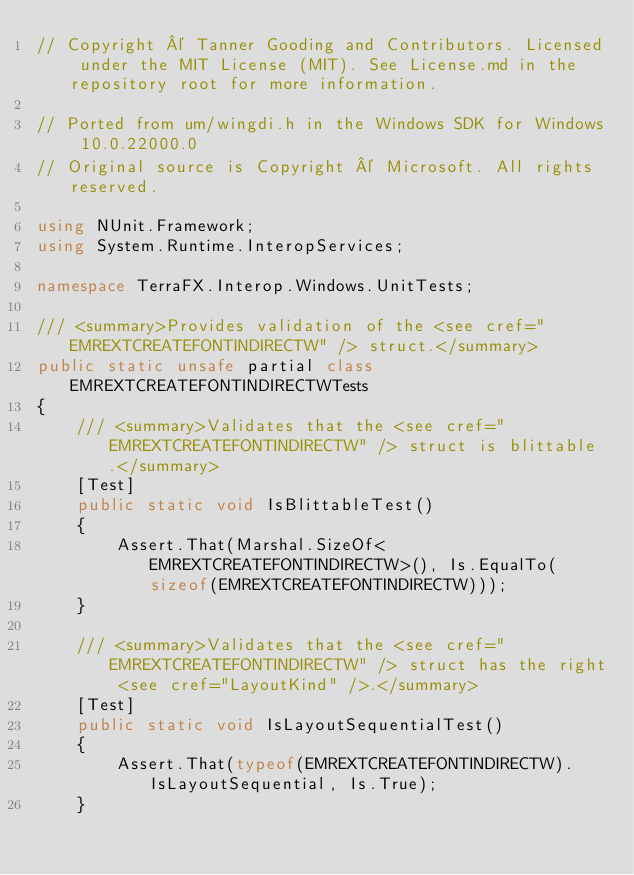<code> <loc_0><loc_0><loc_500><loc_500><_C#_>// Copyright © Tanner Gooding and Contributors. Licensed under the MIT License (MIT). See License.md in the repository root for more information.

// Ported from um/wingdi.h in the Windows SDK for Windows 10.0.22000.0
// Original source is Copyright © Microsoft. All rights reserved.

using NUnit.Framework;
using System.Runtime.InteropServices;

namespace TerraFX.Interop.Windows.UnitTests;

/// <summary>Provides validation of the <see cref="EMREXTCREATEFONTINDIRECTW" /> struct.</summary>
public static unsafe partial class EMREXTCREATEFONTINDIRECTWTests
{
    /// <summary>Validates that the <see cref="EMREXTCREATEFONTINDIRECTW" /> struct is blittable.</summary>
    [Test]
    public static void IsBlittableTest()
    {
        Assert.That(Marshal.SizeOf<EMREXTCREATEFONTINDIRECTW>(), Is.EqualTo(sizeof(EMREXTCREATEFONTINDIRECTW)));
    }

    /// <summary>Validates that the <see cref="EMREXTCREATEFONTINDIRECTW" /> struct has the right <see cref="LayoutKind" />.</summary>
    [Test]
    public static void IsLayoutSequentialTest()
    {
        Assert.That(typeof(EMREXTCREATEFONTINDIRECTW).IsLayoutSequential, Is.True);
    }
</code> 